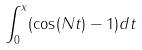<formula> <loc_0><loc_0><loc_500><loc_500>\int _ { 0 } ^ { x } ( \cos ( N t ) - 1 ) d t</formula> 